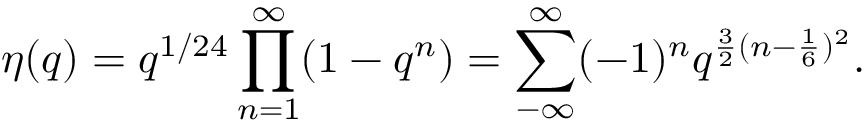<formula> <loc_0><loc_0><loc_500><loc_500>\eta ( q ) = q ^ { 1 / 2 4 } \prod _ { n = 1 } ^ { \infty } ( 1 - q ^ { n } ) = \sum _ { - \infty } ^ { \infty } ( - 1 ) ^ { n } q ^ { \frac { 3 } { 2 } ( n - \frac { 1 } { 6 } ) ^ { 2 } } .</formula> 